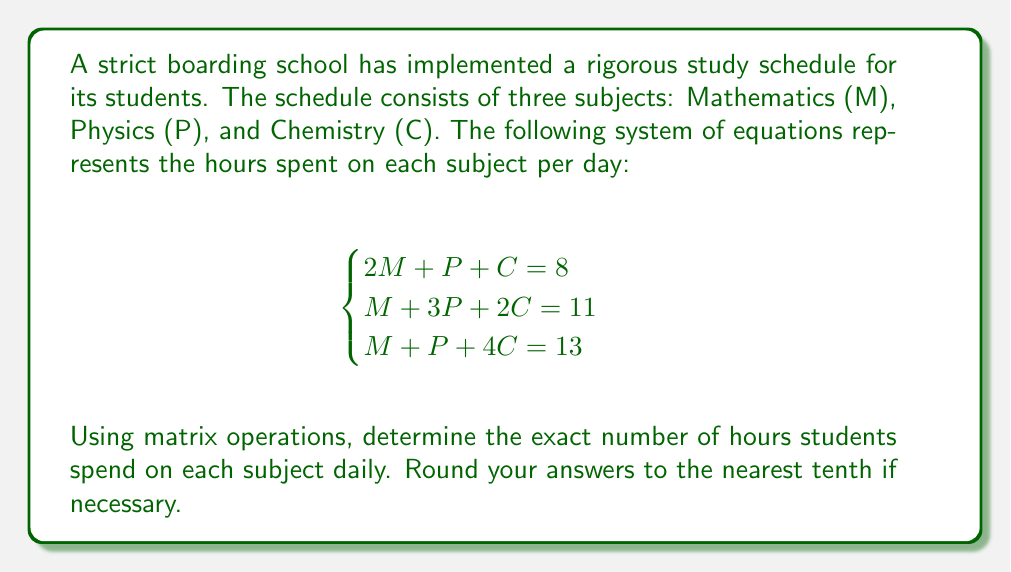Could you help me with this problem? Let's solve this system using matrix operations:

1) First, we'll express the system as an augmented matrix:

   $$
   \begin{bmatrix}
   2 & 1 & 1 & | & 8 \\
   1 & 3 & 2 & | & 11 \\
   1 & 1 & 4 & | & 13
   \end{bmatrix}
   $$

2) We'll use Gaussian elimination to transform this into row echelon form:

   R2 = R2 - R1/2:
   $$
   \begin{bmatrix}
   2 & 1 & 1 & | & 8 \\
   0 & 5/2 & 3/2 & | & 7 \\
   1 & 1 & 4 & | & 13
   \end{bmatrix}
   $$

   R3 = R3 - R1/2:
   $$
   \begin{bmatrix}
   2 & 1 & 1 & | & 8 \\
   0 & 5/2 & 3/2 & | & 7 \\
   0 & 1/2 & 7/2 & | & 9
   \end{bmatrix}
   $$

3) Now, we'll continue to reduce:

   R3 = R3 - R2/5:
   $$
   \begin{bmatrix}
   2 & 1 & 1 & | & 8 \\
   0 & 5/2 & 3/2 & | & 7 \\
   0 & 0 & 13/5 & | & 31/5
   \end{bmatrix}
   $$

4) Now we have the matrix in row echelon form. We can solve for C, P, and M in reverse order:

   C = (31/5) / (13/5) = 31/13

   P = (7 - 3/2 * 31/13) / (5/2) = 23/13

   M = (8 - 31/13 - 23/13) / 2 = 24/13

5) Converting to decimals:

   C ≈ 2.4 hours
   P ≈ 1.8 hours
   M ≈ 1.8 hours

Therefore, students spend approximately 1.8 hours on Mathematics, 1.8 hours on Physics, and 2.4 hours on Chemistry daily.
Answer: M ≈ 1.8, P ≈ 1.8, C ≈ 2.4 